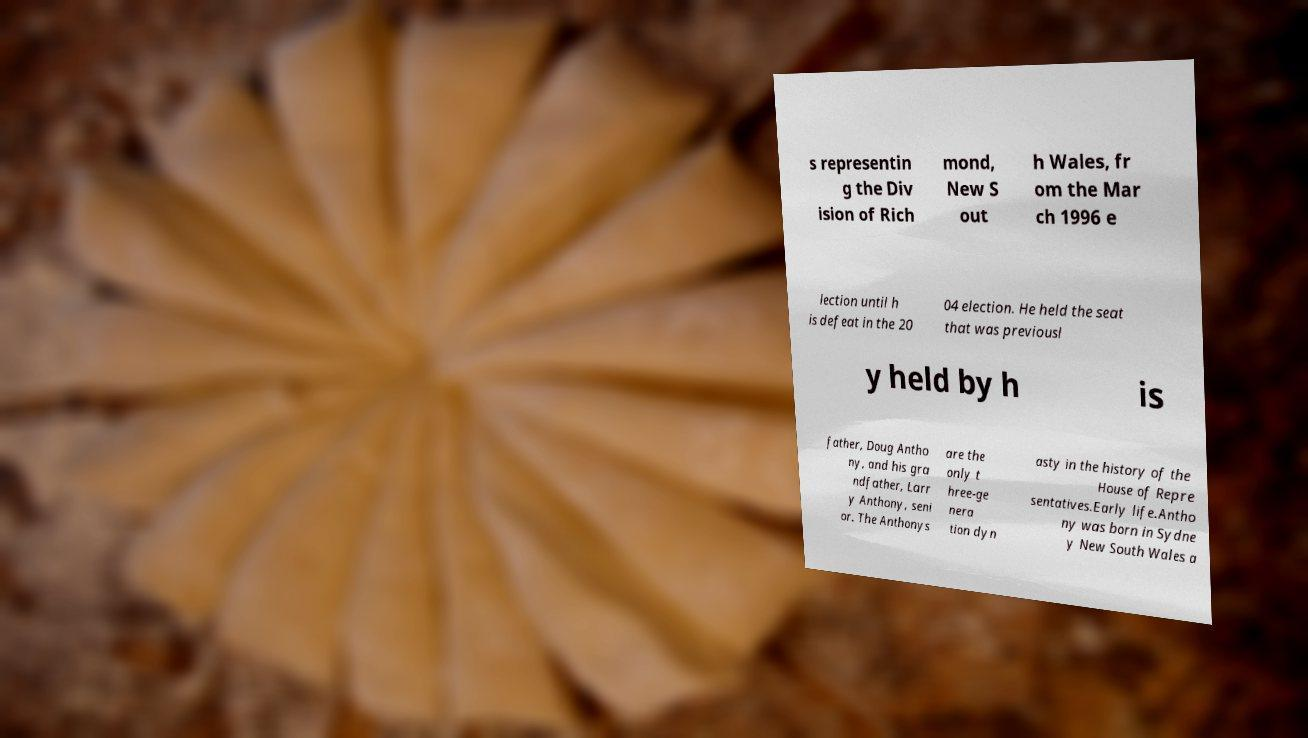What messages or text are displayed in this image? I need them in a readable, typed format. s representin g the Div ision of Rich mond, New S out h Wales, fr om the Mar ch 1996 e lection until h is defeat in the 20 04 election. He held the seat that was previousl y held by h is father, Doug Antho ny, and his gra ndfather, Larr y Anthony, seni or. The Anthonys are the only t hree-ge nera tion dyn asty in the history of the House of Repre sentatives.Early life.Antho ny was born in Sydne y New South Wales a 